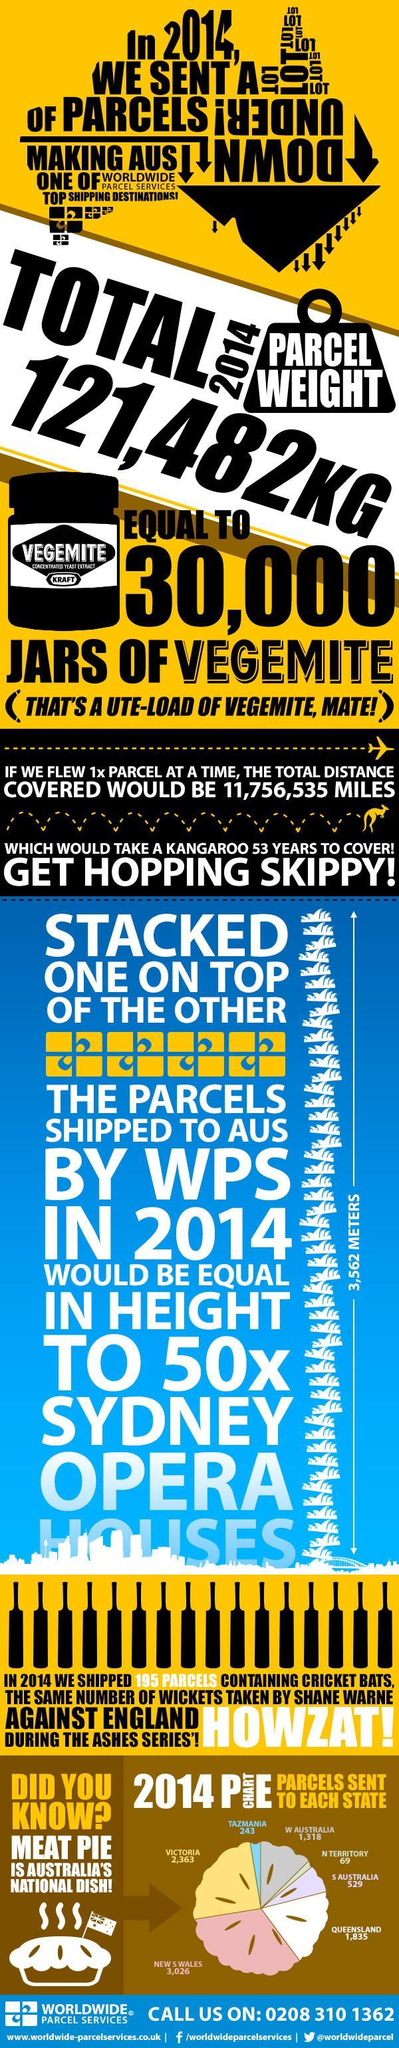What is the number of meat pie parcels sent to Tazmania in 2014?
Answer the question with a short phrase. 243 What is the number of meat pie parcels sent to Queensland in 2014? 1,835 Which dish is called as Australia's national dish? Meat pie Which state in Australia received least no of meat pie parcels in 2014? N TERRITORY Which state in Australia received highest no of meat pie parcels in 2014? NEW S WALES What is the number of meat pie parcels sent to Victoria in 2014? 2,363 What is the total parcel weight sent by Australia in the year 2014? 121,482KG 